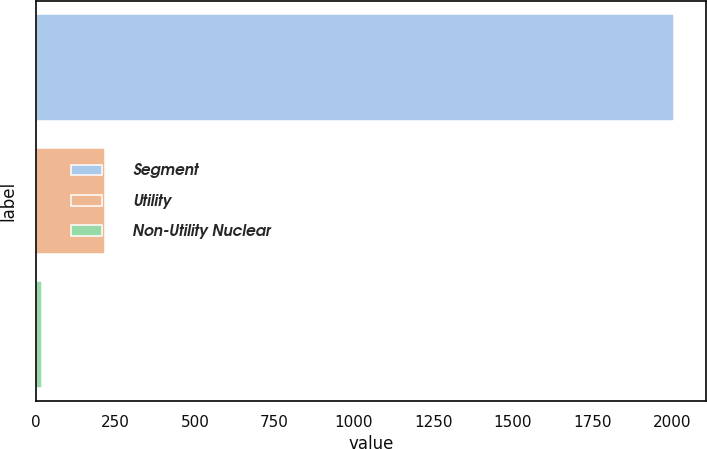<chart> <loc_0><loc_0><loc_500><loc_500><bar_chart><fcel>Segment<fcel>Utility<fcel>Non-Utility Nuclear<nl><fcel>2007<fcel>216.9<fcel>18<nl></chart> 